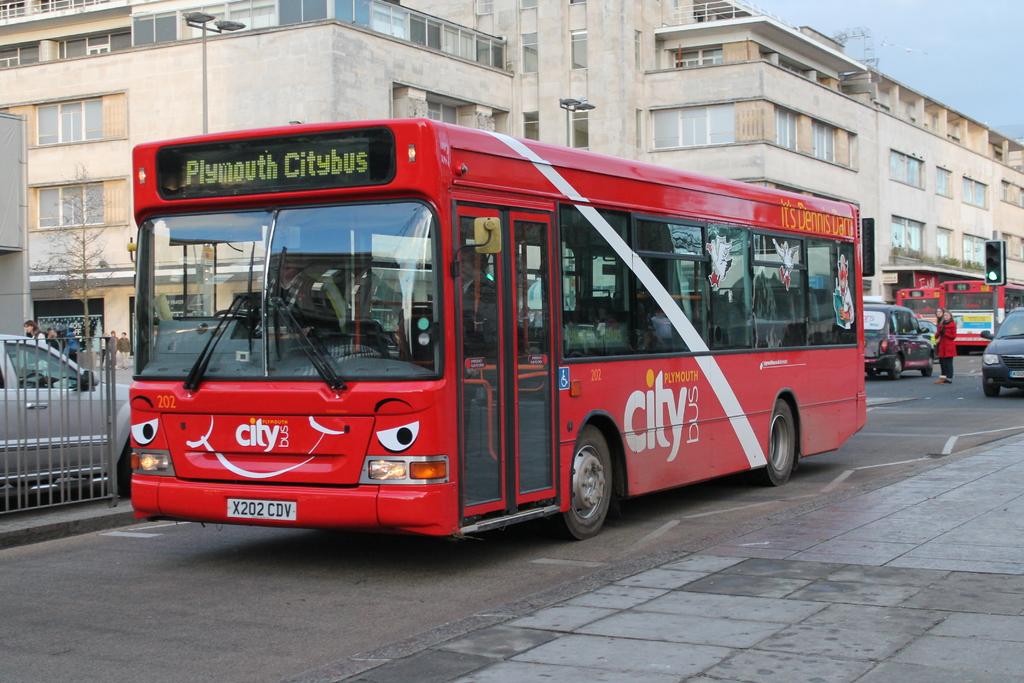What is the license plate number of the bus?
Give a very brief answer. X202 cdv. What city is listed on the bus?
Ensure brevity in your answer.  Plymouth. 